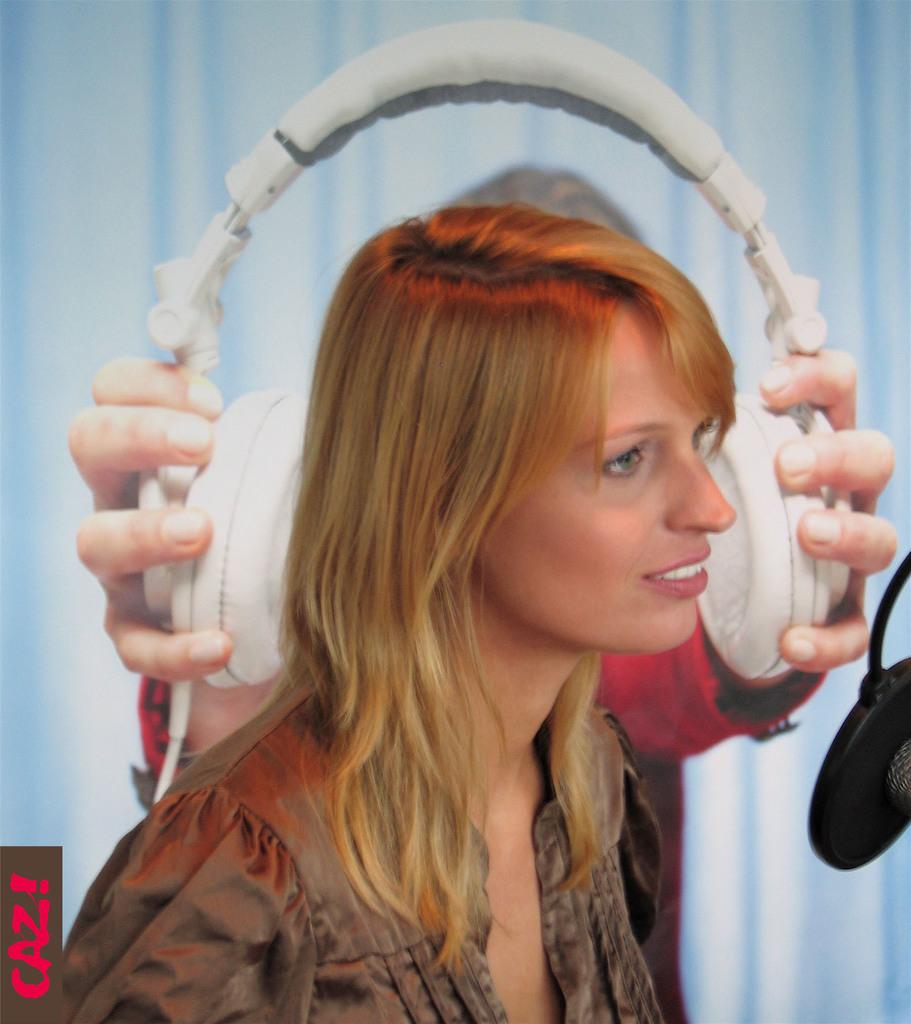Who is present in the image? There is a woman in the image. What can be seen in the background of the image? There is a person holding headsets and a curtain in the background. Can you describe the object on the right side of the image? Unfortunately, the facts provided do not give enough information to describe the object on the right side of the image. How many oranges are on the coil in the bedroom? There is no mention of oranges, coils, or a bedroom in the image, so we cannot answer this question. 